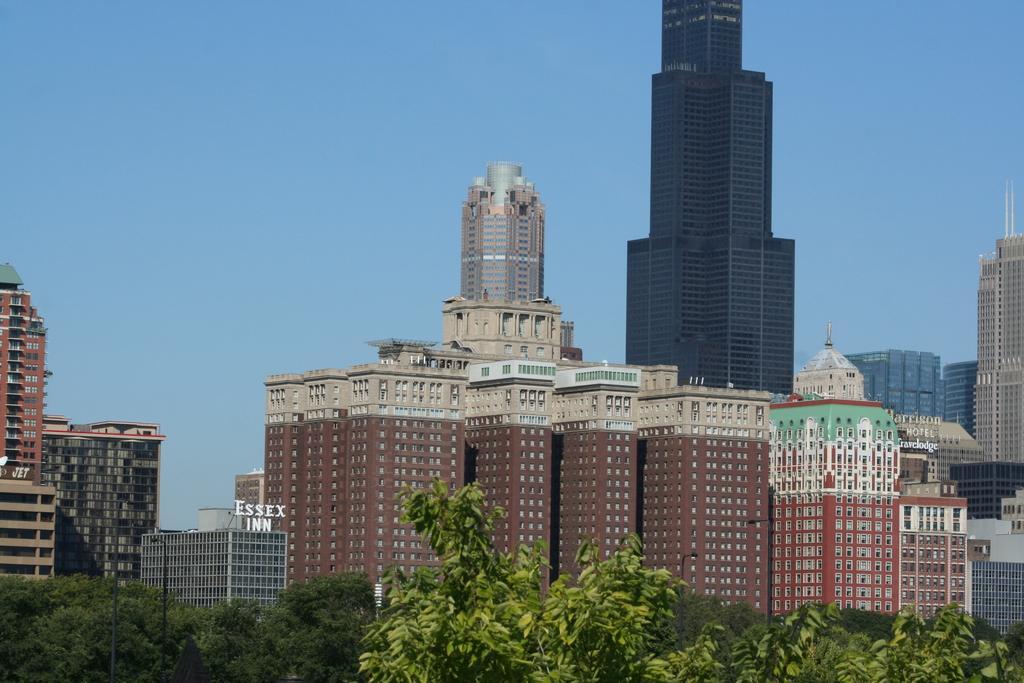How would you summarize this image in a sentence or two? In this image I can see trees in green color, at back I can see few buildings they are in brown, cream, gray color and the sky is in blue color. 